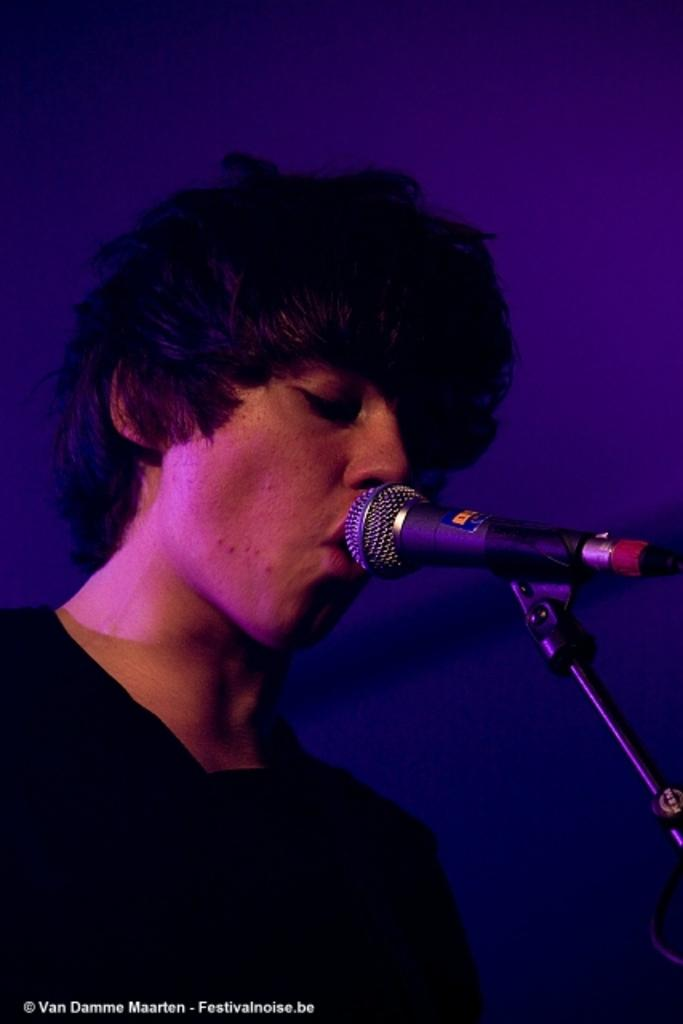What is the main subject of the image? There is a man in the image. What is the man doing in the image? The man is standing and singing in the image. What tool is the man using while singing? The man is using a microphone in the image. What color is the background of the image? The background of the image is violet in color. How many trucks are parked behind the man in the image? There are no trucks visible in the image; the background is violet in color. What type of magic is the man performing with the microphone? The man is not performing any magic in the image; he is simply singing while using a microphone. 